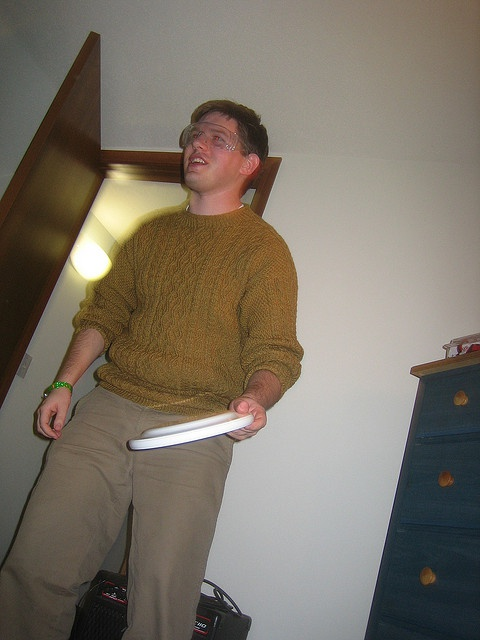Describe the objects in this image and their specific colors. I can see people in gray, olive, and maroon tones and frisbee in gray, white, darkgray, and tan tones in this image. 